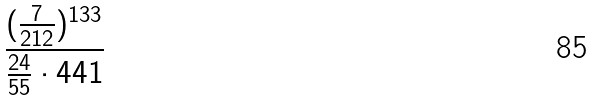<formula> <loc_0><loc_0><loc_500><loc_500>\frac { ( \frac { 7 } { 2 1 2 } ) ^ { 1 3 3 } } { \frac { 2 4 } { 5 5 } \cdot 4 4 1 }</formula> 